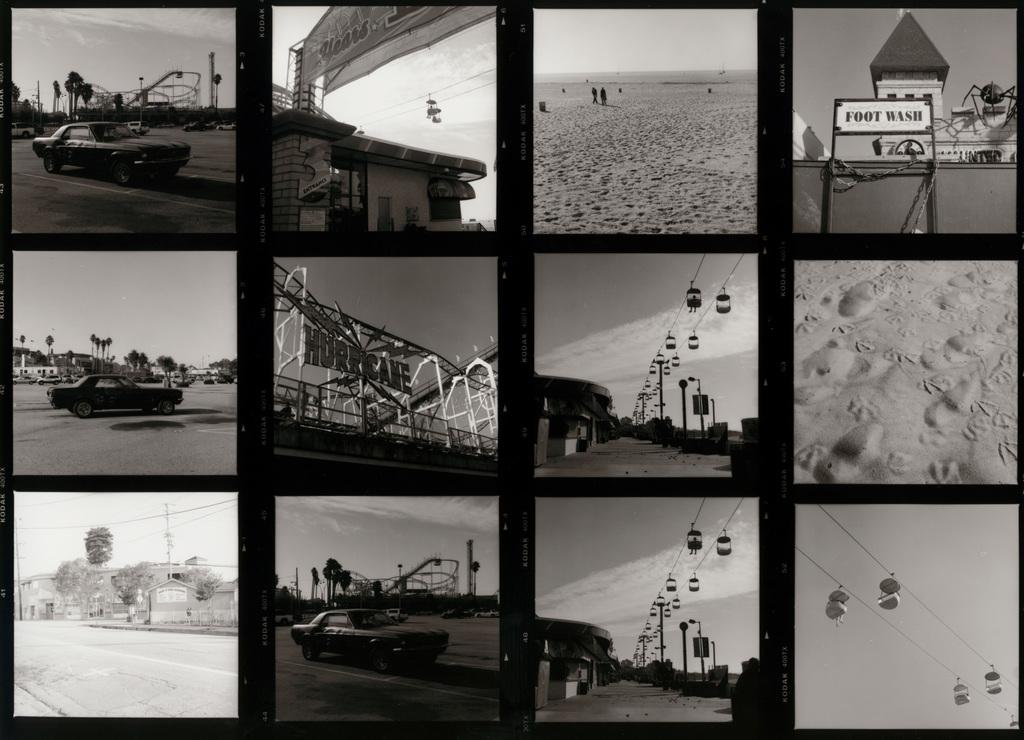What type of image is being described? The image is a photo collage. What can be seen happening on the road in the image? Cars are moving on the road in the image. What structures are present on the right side of the image? There are skyways on the right side of the image. What type of drink is being served in the image? There is no drink present in the image; it is a photo collage featuring cars and skyways. How does the faucet feel about the traffic situation in the image? There is no faucet present in the image, and therefore it cannot have any feelings about the traffic situation. 